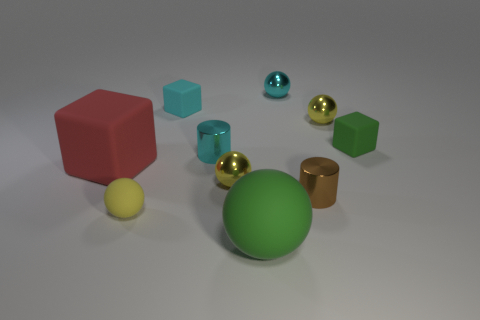Is there a green thing that has the same shape as the cyan matte object?
Offer a terse response. Yes. There is a green object that is the same size as the red cube; what is its shape?
Your answer should be compact. Sphere. How many tiny shiny things are the same color as the big rubber sphere?
Ensure brevity in your answer.  0. What is the size of the metallic sphere that is right of the small cyan ball?
Offer a very short reply. Small. How many cyan metallic things have the same size as the cyan metallic cylinder?
Your response must be concise. 1. What is the color of the big block that is the same material as the green sphere?
Provide a succinct answer. Red. Is the number of big blocks behind the cyan cylinder less than the number of small green things?
Ensure brevity in your answer.  Yes. The tiny cyan object that is made of the same material as the cyan cylinder is what shape?
Offer a very short reply. Sphere. How many matte objects are either tiny blue cylinders or small things?
Ensure brevity in your answer.  3. Is the number of small metal spheres that are in front of the cyan shiny cylinder the same as the number of small yellow spheres?
Offer a terse response. No. 